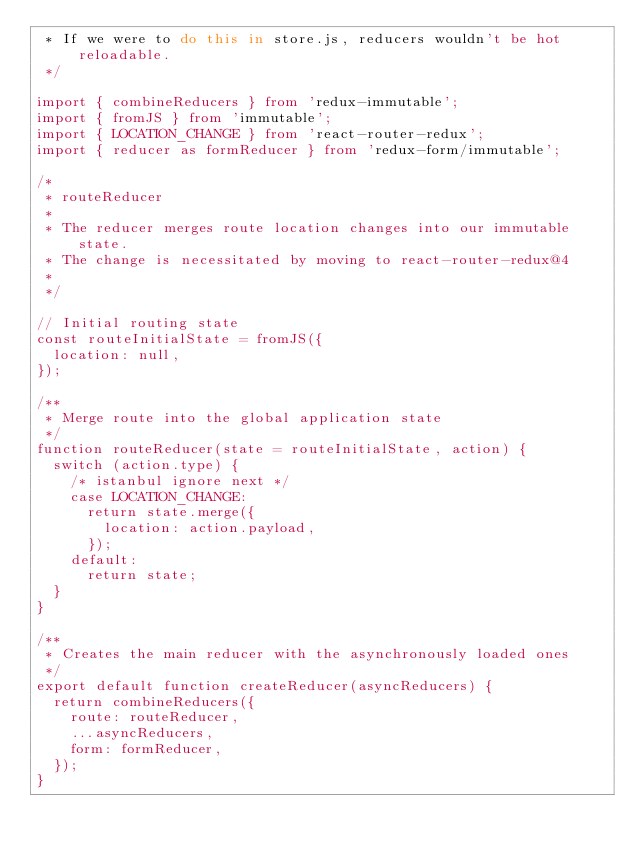<code> <loc_0><loc_0><loc_500><loc_500><_JavaScript_> * If we were to do this in store.js, reducers wouldn't be hot reloadable.
 */

import { combineReducers } from 'redux-immutable';
import { fromJS } from 'immutable';
import { LOCATION_CHANGE } from 'react-router-redux';
import { reducer as formReducer } from 'redux-form/immutable';

/*
 * routeReducer
 *
 * The reducer merges route location changes into our immutable state.
 * The change is necessitated by moving to react-router-redux@4
 *
 */

// Initial routing state
const routeInitialState = fromJS({
  location: null,
});

/**
 * Merge route into the global application state
 */
function routeReducer(state = routeInitialState, action) {
  switch (action.type) {
    /* istanbul ignore next */
    case LOCATION_CHANGE:
      return state.merge({
        location: action.payload,
      });
    default:
      return state;
  }
}

/**
 * Creates the main reducer with the asynchronously loaded ones
 */
export default function createReducer(asyncReducers) {
  return combineReducers({
    route: routeReducer,
    ...asyncReducers,
    form: formReducer,
  });
}
</code> 